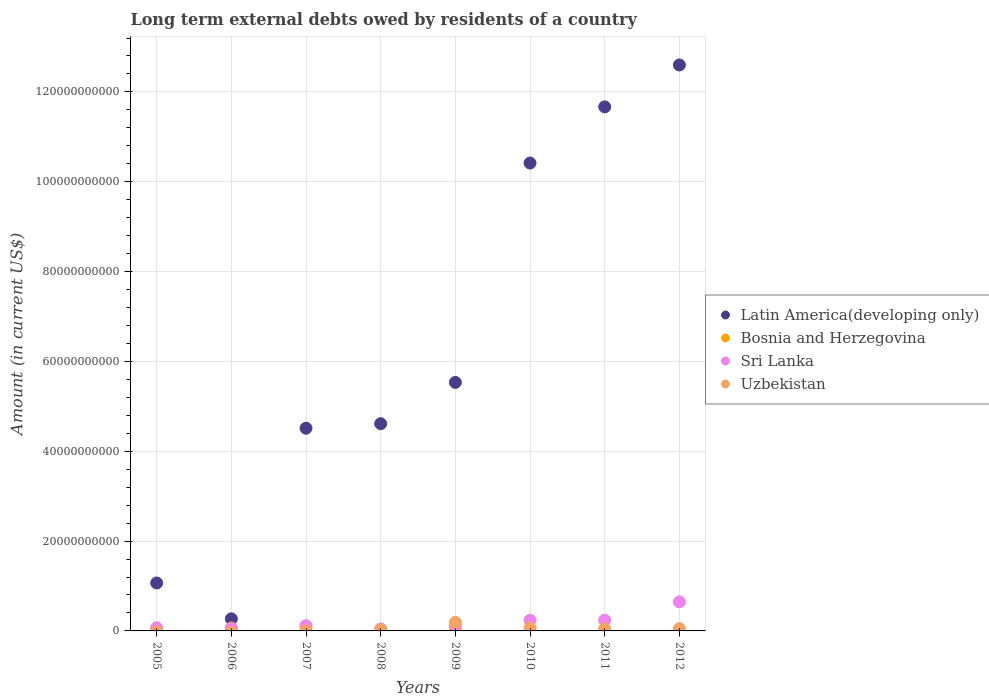Is the number of dotlines equal to the number of legend labels?
Offer a terse response. No. What is the amount of long-term external debts owed by residents in Sri Lanka in 2009?
Make the answer very short. 1.25e+09. Across all years, what is the maximum amount of long-term external debts owed by residents in Uzbekistan?
Offer a very short reply. 1.90e+09. Across all years, what is the minimum amount of long-term external debts owed by residents in Sri Lanka?
Offer a terse response. 4.30e+08. In which year was the amount of long-term external debts owed by residents in Sri Lanka maximum?
Provide a short and direct response. 2012. What is the total amount of long-term external debts owed by residents in Sri Lanka in the graph?
Offer a terse response. 1.53e+1. What is the difference between the amount of long-term external debts owed by residents in Sri Lanka in 2011 and that in 2012?
Ensure brevity in your answer.  -4.08e+09. What is the difference between the amount of long-term external debts owed by residents in Bosnia and Herzegovina in 2006 and the amount of long-term external debts owed by residents in Latin America(developing only) in 2007?
Your answer should be very brief. -4.45e+1. What is the average amount of long-term external debts owed by residents in Bosnia and Herzegovina per year?
Your response must be concise. 3.22e+08. In the year 2005, what is the difference between the amount of long-term external debts owed by residents in Bosnia and Herzegovina and amount of long-term external debts owed by residents in Latin America(developing only)?
Provide a succinct answer. -1.02e+1. What is the ratio of the amount of long-term external debts owed by residents in Uzbekistan in 2009 to that in 2012?
Provide a short and direct response. 3.71. What is the difference between the highest and the second highest amount of long-term external debts owed by residents in Uzbekistan?
Provide a succinct answer. 1.20e+09. What is the difference between the highest and the lowest amount of long-term external debts owed by residents in Bosnia and Herzegovina?
Offer a very short reply. 9.13e+08. Is it the case that in every year, the sum of the amount of long-term external debts owed by residents in Latin America(developing only) and amount of long-term external debts owed by residents in Bosnia and Herzegovina  is greater than the sum of amount of long-term external debts owed by residents in Uzbekistan and amount of long-term external debts owed by residents in Sri Lanka?
Keep it short and to the point. No. Is it the case that in every year, the sum of the amount of long-term external debts owed by residents in Latin America(developing only) and amount of long-term external debts owed by residents in Sri Lanka  is greater than the amount of long-term external debts owed by residents in Bosnia and Herzegovina?
Offer a very short reply. Yes. Does the amount of long-term external debts owed by residents in Bosnia and Herzegovina monotonically increase over the years?
Make the answer very short. No. What is the difference between two consecutive major ticks on the Y-axis?
Offer a very short reply. 2.00e+1. Are the values on the major ticks of Y-axis written in scientific E-notation?
Ensure brevity in your answer.  No. Does the graph contain any zero values?
Provide a succinct answer. Yes. Does the graph contain grids?
Keep it short and to the point. Yes. Where does the legend appear in the graph?
Offer a terse response. Center right. What is the title of the graph?
Offer a very short reply. Long term external debts owed by residents of a country. Does "Eritrea" appear as one of the legend labels in the graph?
Keep it short and to the point. No. What is the label or title of the Y-axis?
Provide a short and direct response. Amount (in current US$). What is the Amount (in current US$) in Latin America(developing only) in 2005?
Ensure brevity in your answer.  1.07e+1. What is the Amount (in current US$) in Bosnia and Herzegovina in 2005?
Offer a very short reply. 4.45e+08. What is the Amount (in current US$) in Sri Lanka in 2005?
Your answer should be compact. 6.84e+08. What is the Amount (in current US$) of Uzbekistan in 2005?
Provide a short and direct response. 0. What is the Amount (in current US$) of Latin America(developing only) in 2006?
Keep it short and to the point. 2.69e+09. What is the Amount (in current US$) of Bosnia and Herzegovina in 2006?
Give a very brief answer. 6.58e+08. What is the Amount (in current US$) in Sri Lanka in 2006?
Your answer should be compact. 5.33e+08. What is the Amount (in current US$) of Latin America(developing only) in 2007?
Offer a very short reply. 4.51e+1. What is the Amount (in current US$) in Bosnia and Herzegovina in 2007?
Make the answer very short. 9.13e+08. What is the Amount (in current US$) of Sri Lanka in 2007?
Your answer should be compact. 1.16e+09. What is the Amount (in current US$) of Uzbekistan in 2007?
Provide a short and direct response. 2.23e+07. What is the Amount (in current US$) of Latin America(developing only) in 2008?
Keep it short and to the point. 4.61e+1. What is the Amount (in current US$) in Bosnia and Herzegovina in 2008?
Ensure brevity in your answer.  3.35e+08. What is the Amount (in current US$) of Sri Lanka in 2008?
Offer a terse response. 4.30e+08. What is the Amount (in current US$) of Uzbekistan in 2008?
Your answer should be compact. 2.96e+08. What is the Amount (in current US$) of Latin America(developing only) in 2009?
Your answer should be very brief. 5.53e+1. What is the Amount (in current US$) in Bosnia and Herzegovina in 2009?
Offer a terse response. 2.23e+08. What is the Amount (in current US$) of Sri Lanka in 2009?
Provide a short and direct response. 1.25e+09. What is the Amount (in current US$) of Uzbekistan in 2009?
Your response must be concise. 1.90e+09. What is the Amount (in current US$) of Latin America(developing only) in 2010?
Ensure brevity in your answer.  1.04e+11. What is the Amount (in current US$) in Sri Lanka in 2010?
Give a very brief answer. 2.38e+09. What is the Amount (in current US$) in Uzbekistan in 2010?
Your response must be concise. 6.98e+08. What is the Amount (in current US$) in Latin America(developing only) in 2011?
Keep it short and to the point. 1.17e+11. What is the Amount (in current US$) in Sri Lanka in 2011?
Your answer should be compact. 2.39e+09. What is the Amount (in current US$) of Uzbekistan in 2011?
Provide a short and direct response. 4.87e+08. What is the Amount (in current US$) of Latin America(developing only) in 2012?
Provide a short and direct response. 1.26e+11. What is the Amount (in current US$) in Sri Lanka in 2012?
Provide a short and direct response. 6.47e+09. What is the Amount (in current US$) in Uzbekistan in 2012?
Keep it short and to the point. 5.12e+08. Across all years, what is the maximum Amount (in current US$) of Latin America(developing only)?
Make the answer very short. 1.26e+11. Across all years, what is the maximum Amount (in current US$) in Bosnia and Herzegovina?
Keep it short and to the point. 9.13e+08. Across all years, what is the maximum Amount (in current US$) in Sri Lanka?
Your response must be concise. 6.47e+09. Across all years, what is the maximum Amount (in current US$) in Uzbekistan?
Offer a very short reply. 1.90e+09. Across all years, what is the minimum Amount (in current US$) of Latin America(developing only)?
Make the answer very short. 2.69e+09. Across all years, what is the minimum Amount (in current US$) in Bosnia and Herzegovina?
Your response must be concise. 0. Across all years, what is the minimum Amount (in current US$) of Sri Lanka?
Your answer should be very brief. 4.30e+08. Across all years, what is the minimum Amount (in current US$) of Uzbekistan?
Your response must be concise. 0. What is the total Amount (in current US$) of Latin America(developing only) in the graph?
Offer a terse response. 5.07e+11. What is the total Amount (in current US$) of Bosnia and Herzegovina in the graph?
Offer a terse response. 2.57e+09. What is the total Amount (in current US$) in Sri Lanka in the graph?
Make the answer very short. 1.53e+1. What is the total Amount (in current US$) of Uzbekistan in the graph?
Provide a succinct answer. 3.91e+09. What is the difference between the Amount (in current US$) in Latin America(developing only) in 2005 and that in 2006?
Provide a short and direct response. 7.98e+09. What is the difference between the Amount (in current US$) in Bosnia and Herzegovina in 2005 and that in 2006?
Keep it short and to the point. -2.13e+08. What is the difference between the Amount (in current US$) in Sri Lanka in 2005 and that in 2006?
Offer a very short reply. 1.50e+08. What is the difference between the Amount (in current US$) of Latin America(developing only) in 2005 and that in 2007?
Make the answer very short. -3.45e+1. What is the difference between the Amount (in current US$) in Bosnia and Herzegovina in 2005 and that in 2007?
Provide a short and direct response. -4.69e+08. What is the difference between the Amount (in current US$) in Sri Lanka in 2005 and that in 2007?
Provide a succinct answer. -4.72e+08. What is the difference between the Amount (in current US$) of Latin America(developing only) in 2005 and that in 2008?
Give a very brief answer. -3.55e+1. What is the difference between the Amount (in current US$) of Bosnia and Herzegovina in 2005 and that in 2008?
Make the answer very short. 1.10e+08. What is the difference between the Amount (in current US$) of Sri Lanka in 2005 and that in 2008?
Your answer should be very brief. 2.54e+08. What is the difference between the Amount (in current US$) of Latin America(developing only) in 2005 and that in 2009?
Offer a very short reply. -4.46e+1. What is the difference between the Amount (in current US$) in Bosnia and Herzegovina in 2005 and that in 2009?
Your response must be concise. 2.21e+08. What is the difference between the Amount (in current US$) in Sri Lanka in 2005 and that in 2009?
Keep it short and to the point. -5.63e+08. What is the difference between the Amount (in current US$) in Latin America(developing only) in 2005 and that in 2010?
Ensure brevity in your answer.  -9.35e+1. What is the difference between the Amount (in current US$) of Sri Lanka in 2005 and that in 2010?
Give a very brief answer. -1.69e+09. What is the difference between the Amount (in current US$) of Latin America(developing only) in 2005 and that in 2011?
Offer a very short reply. -1.06e+11. What is the difference between the Amount (in current US$) of Sri Lanka in 2005 and that in 2011?
Provide a succinct answer. -1.71e+09. What is the difference between the Amount (in current US$) in Latin America(developing only) in 2005 and that in 2012?
Provide a short and direct response. -1.15e+11. What is the difference between the Amount (in current US$) of Sri Lanka in 2005 and that in 2012?
Ensure brevity in your answer.  -5.78e+09. What is the difference between the Amount (in current US$) of Latin America(developing only) in 2006 and that in 2007?
Your answer should be compact. -4.24e+1. What is the difference between the Amount (in current US$) in Bosnia and Herzegovina in 2006 and that in 2007?
Make the answer very short. -2.56e+08. What is the difference between the Amount (in current US$) of Sri Lanka in 2006 and that in 2007?
Keep it short and to the point. -6.22e+08. What is the difference between the Amount (in current US$) of Latin America(developing only) in 2006 and that in 2008?
Offer a terse response. -4.34e+1. What is the difference between the Amount (in current US$) of Bosnia and Herzegovina in 2006 and that in 2008?
Provide a short and direct response. 3.23e+08. What is the difference between the Amount (in current US$) of Sri Lanka in 2006 and that in 2008?
Your answer should be very brief. 1.04e+08. What is the difference between the Amount (in current US$) in Latin America(developing only) in 2006 and that in 2009?
Offer a very short reply. -5.26e+1. What is the difference between the Amount (in current US$) of Bosnia and Herzegovina in 2006 and that in 2009?
Make the answer very short. 4.34e+08. What is the difference between the Amount (in current US$) in Sri Lanka in 2006 and that in 2009?
Your answer should be compact. -7.14e+08. What is the difference between the Amount (in current US$) in Latin America(developing only) in 2006 and that in 2010?
Ensure brevity in your answer.  -1.01e+11. What is the difference between the Amount (in current US$) in Sri Lanka in 2006 and that in 2010?
Keep it short and to the point. -1.84e+09. What is the difference between the Amount (in current US$) in Latin America(developing only) in 2006 and that in 2011?
Offer a terse response. -1.14e+11. What is the difference between the Amount (in current US$) of Sri Lanka in 2006 and that in 2011?
Give a very brief answer. -1.86e+09. What is the difference between the Amount (in current US$) in Latin America(developing only) in 2006 and that in 2012?
Provide a short and direct response. -1.23e+11. What is the difference between the Amount (in current US$) in Sri Lanka in 2006 and that in 2012?
Ensure brevity in your answer.  -5.93e+09. What is the difference between the Amount (in current US$) of Latin America(developing only) in 2007 and that in 2008?
Your answer should be compact. -1.01e+09. What is the difference between the Amount (in current US$) in Bosnia and Herzegovina in 2007 and that in 2008?
Provide a short and direct response. 5.79e+08. What is the difference between the Amount (in current US$) of Sri Lanka in 2007 and that in 2008?
Ensure brevity in your answer.  7.26e+08. What is the difference between the Amount (in current US$) in Uzbekistan in 2007 and that in 2008?
Offer a very short reply. -2.74e+08. What is the difference between the Amount (in current US$) of Latin America(developing only) in 2007 and that in 2009?
Keep it short and to the point. -1.02e+1. What is the difference between the Amount (in current US$) in Bosnia and Herzegovina in 2007 and that in 2009?
Your answer should be very brief. 6.90e+08. What is the difference between the Amount (in current US$) in Sri Lanka in 2007 and that in 2009?
Give a very brief answer. -9.14e+07. What is the difference between the Amount (in current US$) in Uzbekistan in 2007 and that in 2009?
Provide a short and direct response. -1.88e+09. What is the difference between the Amount (in current US$) in Latin America(developing only) in 2007 and that in 2010?
Make the answer very short. -5.90e+1. What is the difference between the Amount (in current US$) of Sri Lanka in 2007 and that in 2010?
Your answer should be very brief. -1.22e+09. What is the difference between the Amount (in current US$) of Uzbekistan in 2007 and that in 2010?
Provide a short and direct response. -6.76e+08. What is the difference between the Amount (in current US$) of Latin America(developing only) in 2007 and that in 2011?
Your answer should be very brief. -7.15e+1. What is the difference between the Amount (in current US$) in Sri Lanka in 2007 and that in 2011?
Keep it short and to the point. -1.24e+09. What is the difference between the Amount (in current US$) of Uzbekistan in 2007 and that in 2011?
Give a very brief answer. -4.64e+08. What is the difference between the Amount (in current US$) in Latin America(developing only) in 2007 and that in 2012?
Keep it short and to the point. -8.09e+1. What is the difference between the Amount (in current US$) in Sri Lanka in 2007 and that in 2012?
Keep it short and to the point. -5.31e+09. What is the difference between the Amount (in current US$) in Uzbekistan in 2007 and that in 2012?
Make the answer very short. -4.90e+08. What is the difference between the Amount (in current US$) of Latin America(developing only) in 2008 and that in 2009?
Ensure brevity in your answer.  -9.19e+09. What is the difference between the Amount (in current US$) of Bosnia and Herzegovina in 2008 and that in 2009?
Provide a succinct answer. 1.11e+08. What is the difference between the Amount (in current US$) in Sri Lanka in 2008 and that in 2009?
Provide a short and direct response. -8.17e+08. What is the difference between the Amount (in current US$) in Uzbekistan in 2008 and that in 2009?
Keep it short and to the point. -1.60e+09. What is the difference between the Amount (in current US$) in Latin America(developing only) in 2008 and that in 2010?
Your response must be concise. -5.80e+1. What is the difference between the Amount (in current US$) in Sri Lanka in 2008 and that in 2010?
Keep it short and to the point. -1.95e+09. What is the difference between the Amount (in current US$) in Uzbekistan in 2008 and that in 2010?
Keep it short and to the point. -4.02e+08. What is the difference between the Amount (in current US$) of Latin America(developing only) in 2008 and that in 2011?
Give a very brief answer. -7.05e+1. What is the difference between the Amount (in current US$) in Sri Lanka in 2008 and that in 2011?
Provide a succinct answer. -1.96e+09. What is the difference between the Amount (in current US$) in Uzbekistan in 2008 and that in 2011?
Your response must be concise. -1.91e+08. What is the difference between the Amount (in current US$) of Latin America(developing only) in 2008 and that in 2012?
Offer a very short reply. -7.99e+1. What is the difference between the Amount (in current US$) in Sri Lanka in 2008 and that in 2012?
Ensure brevity in your answer.  -6.04e+09. What is the difference between the Amount (in current US$) in Uzbekistan in 2008 and that in 2012?
Provide a short and direct response. -2.16e+08. What is the difference between the Amount (in current US$) of Latin America(developing only) in 2009 and that in 2010?
Provide a succinct answer. -4.88e+1. What is the difference between the Amount (in current US$) in Sri Lanka in 2009 and that in 2010?
Make the answer very short. -1.13e+09. What is the difference between the Amount (in current US$) in Uzbekistan in 2009 and that in 2010?
Offer a very short reply. 1.20e+09. What is the difference between the Amount (in current US$) in Latin America(developing only) in 2009 and that in 2011?
Provide a succinct answer. -6.13e+1. What is the difference between the Amount (in current US$) in Sri Lanka in 2009 and that in 2011?
Your answer should be compact. -1.14e+09. What is the difference between the Amount (in current US$) in Uzbekistan in 2009 and that in 2011?
Your response must be concise. 1.41e+09. What is the difference between the Amount (in current US$) of Latin America(developing only) in 2009 and that in 2012?
Offer a terse response. -7.07e+1. What is the difference between the Amount (in current US$) of Sri Lanka in 2009 and that in 2012?
Your answer should be compact. -5.22e+09. What is the difference between the Amount (in current US$) in Uzbekistan in 2009 and that in 2012?
Provide a short and direct response. 1.39e+09. What is the difference between the Amount (in current US$) in Latin America(developing only) in 2010 and that in 2011?
Your answer should be very brief. -1.25e+1. What is the difference between the Amount (in current US$) in Sri Lanka in 2010 and that in 2011?
Give a very brief answer. -1.54e+07. What is the difference between the Amount (in current US$) in Uzbekistan in 2010 and that in 2011?
Provide a succinct answer. 2.11e+08. What is the difference between the Amount (in current US$) in Latin America(developing only) in 2010 and that in 2012?
Keep it short and to the point. -2.18e+1. What is the difference between the Amount (in current US$) in Sri Lanka in 2010 and that in 2012?
Ensure brevity in your answer.  -4.09e+09. What is the difference between the Amount (in current US$) in Uzbekistan in 2010 and that in 2012?
Your response must be concise. 1.86e+08. What is the difference between the Amount (in current US$) in Latin America(developing only) in 2011 and that in 2012?
Make the answer very short. -9.33e+09. What is the difference between the Amount (in current US$) of Sri Lanka in 2011 and that in 2012?
Offer a very short reply. -4.08e+09. What is the difference between the Amount (in current US$) of Uzbekistan in 2011 and that in 2012?
Provide a short and direct response. -2.52e+07. What is the difference between the Amount (in current US$) in Latin America(developing only) in 2005 and the Amount (in current US$) in Bosnia and Herzegovina in 2006?
Offer a very short reply. 1.00e+1. What is the difference between the Amount (in current US$) of Latin America(developing only) in 2005 and the Amount (in current US$) of Sri Lanka in 2006?
Offer a very short reply. 1.01e+1. What is the difference between the Amount (in current US$) of Bosnia and Herzegovina in 2005 and the Amount (in current US$) of Sri Lanka in 2006?
Provide a succinct answer. -8.87e+07. What is the difference between the Amount (in current US$) of Latin America(developing only) in 2005 and the Amount (in current US$) of Bosnia and Herzegovina in 2007?
Offer a very short reply. 9.76e+09. What is the difference between the Amount (in current US$) in Latin America(developing only) in 2005 and the Amount (in current US$) in Sri Lanka in 2007?
Ensure brevity in your answer.  9.52e+09. What is the difference between the Amount (in current US$) of Latin America(developing only) in 2005 and the Amount (in current US$) of Uzbekistan in 2007?
Provide a succinct answer. 1.07e+1. What is the difference between the Amount (in current US$) of Bosnia and Herzegovina in 2005 and the Amount (in current US$) of Sri Lanka in 2007?
Give a very brief answer. -7.11e+08. What is the difference between the Amount (in current US$) of Bosnia and Herzegovina in 2005 and the Amount (in current US$) of Uzbekistan in 2007?
Give a very brief answer. 4.22e+08. What is the difference between the Amount (in current US$) of Sri Lanka in 2005 and the Amount (in current US$) of Uzbekistan in 2007?
Keep it short and to the point. 6.62e+08. What is the difference between the Amount (in current US$) of Latin America(developing only) in 2005 and the Amount (in current US$) of Bosnia and Herzegovina in 2008?
Offer a terse response. 1.03e+1. What is the difference between the Amount (in current US$) of Latin America(developing only) in 2005 and the Amount (in current US$) of Sri Lanka in 2008?
Make the answer very short. 1.02e+1. What is the difference between the Amount (in current US$) in Latin America(developing only) in 2005 and the Amount (in current US$) in Uzbekistan in 2008?
Make the answer very short. 1.04e+1. What is the difference between the Amount (in current US$) of Bosnia and Herzegovina in 2005 and the Amount (in current US$) of Sri Lanka in 2008?
Make the answer very short. 1.50e+07. What is the difference between the Amount (in current US$) of Bosnia and Herzegovina in 2005 and the Amount (in current US$) of Uzbekistan in 2008?
Your answer should be compact. 1.48e+08. What is the difference between the Amount (in current US$) in Sri Lanka in 2005 and the Amount (in current US$) in Uzbekistan in 2008?
Keep it short and to the point. 3.88e+08. What is the difference between the Amount (in current US$) in Latin America(developing only) in 2005 and the Amount (in current US$) in Bosnia and Herzegovina in 2009?
Give a very brief answer. 1.05e+1. What is the difference between the Amount (in current US$) in Latin America(developing only) in 2005 and the Amount (in current US$) in Sri Lanka in 2009?
Ensure brevity in your answer.  9.43e+09. What is the difference between the Amount (in current US$) in Latin America(developing only) in 2005 and the Amount (in current US$) in Uzbekistan in 2009?
Give a very brief answer. 8.78e+09. What is the difference between the Amount (in current US$) in Bosnia and Herzegovina in 2005 and the Amount (in current US$) in Sri Lanka in 2009?
Keep it short and to the point. -8.02e+08. What is the difference between the Amount (in current US$) in Bosnia and Herzegovina in 2005 and the Amount (in current US$) in Uzbekistan in 2009?
Provide a short and direct response. -1.45e+09. What is the difference between the Amount (in current US$) of Sri Lanka in 2005 and the Amount (in current US$) of Uzbekistan in 2009?
Provide a short and direct response. -1.22e+09. What is the difference between the Amount (in current US$) in Latin America(developing only) in 2005 and the Amount (in current US$) in Sri Lanka in 2010?
Provide a short and direct response. 8.30e+09. What is the difference between the Amount (in current US$) in Latin America(developing only) in 2005 and the Amount (in current US$) in Uzbekistan in 2010?
Make the answer very short. 9.98e+09. What is the difference between the Amount (in current US$) in Bosnia and Herzegovina in 2005 and the Amount (in current US$) in Sri Lanka in 2010?
Your response must be concise. -1.93e+09. What is the difference between the Amount (in current US$) of Bosnia and Herzegovina in 2005 and the Amount (in current US$) of Uzbekistan in 2010?
Give a very brief answer. -2.53e+08. What is the difference between the Amount (in current US$) in Sri Lanka in 2005 and the Amount (in current US$) in Uzbekistan in 2010?
Offer a terse response. -1.40e+07. What is the difference between the Amount (in current US$) of Latin America(developing only) in 2005 and the Amount (in current US$) of Sri Lanka in 2011?
Ensure brevity in your answer.  8.28e+09. What is the difference between the Amount (in current US$) of Latin America(developing only) in 2005 and the Amount (in current US$) of Uzbekistan in 2011?
Your answer should be very brief. 1.02e+1. What is the difference between the Amount (in current US$) in Bosnia and Herzegovina in 2005 and the Amount (in current US$) in Sri Lanka in 2011?
Provide a succinct answer. -1.95e+09. What is the difference between the Amount (in current US$) in Bosnia and Herzegovina in 2005 and the Amount (in current US$) in Uzbekistan in 2011?
Your response must be concise. -4.22e+07. What is the difference between the Amount (in current US$) in Sri Lanka in 2005 and the Amount (in current US$) in Uzbekistan in 2011?
Keep it short and to the point. 1.97e+08. What is the difference between the Amount (in current US$) of Latin America(developing only) in 2005 and the Amount (in current US$) of Sri Lanka in 2012?
Provide a succinct answer. 4.21e+09. What is the difference between the Amount (in current US$) of Latin America(developing only) in 2005 and the Amount (in current US$) of Uzbekistan in 2012?
Offer a very short reply. 1.02e+1. What is the difference between the Amount (in current US$) of Bosnia and Herzegovina in 2005 and the Amount (in current US$) of Sri Lanka in 2012?
Provide a succinct answer. -6.02e+09. What is the difference between the Amount (in current US$) of Bosnia and Herzegovina in 2005 and the Amount (in current US$) of Uzbekistan in 2012?
Provide a short and direct response. -6.74e+07. What is the difference between the Amount (in current US$) of Sri Lanka in 2005 and the Amount (in current US$) of Uzbekistan in 2012?
Your response must be concise. 1.72e+08. What is the difference between the Amount (in current US$) in Latin America(developing only) in 2006 and the Amount (in current US$) in Bosnia and Herzegovina in 2007?
Provide a succinct answer. 1.78e+09. What is the difference between the Amount (in current US$) of Latin America(developing only) in 2006 and the Amount (in current US$) of Sri Lanka in 2007?
Keep it short and to the point. 1.54e+09. What is the difference between the Amount (in current US$) of Latin America(developing only) in 2006 and the Amount (in current US$) of Uzbekistan in 2007?
Keep it short and to the point. 2.67e+09. What is the difference between the Amount (in current US$) of Bosnia and Herzegovina in 2006 and the Amount (in current US$) of Sri Lanka in 2007?
Provide a succinct answer. -4.98e+08. What is the difference between the Amount (in current US$) of Bosnia and Herzegovina in 2006 and the Amount (in current US$) of Uzbekistan in 2007?
Give a very brief answer. 6.35e+08. What is the difference between the Amount (in current US$) in Sri Lanka in 2006 and the Amount (in current US$) in Uzbekistan in 2007?
Provide a short and direct response. 5.11e+08. What is the difference between the Amount (in current US$) in Latin America(developing only) in 2006 and the Amount (in current US$) in Bosnia and Herzegovina in 2008?
Give a very brief answer. 2.36e+09. What is the difference between the Amount (in current US$) of Latin America(developing only) in 2006 and the Amount (in current US$) of Sri Lanka in 2008?
Your response must be concise. 2.26e+09. What is the difference between the Amount (in current US$) of Latin America(developing only) in 2006 and the Amount (in current US$) of Uzbekistan in 2008?
Provide a succinct answer. 2.40e+09. What is the difference between the Amount (in current US$) of Bosnia and Herzegovina in 2006 and the Amount (in current US$) of Sri Lanka in 2008?
Offer a very short reply. 2.28e+08. What is the difference between the Amount (in current US$) in Bosnia and Herzegovina in 2006 and the Amount (in current US$) in Uzbekistan in 2008?
Provide a succinct answer. 3.62e+08. What is the difference between the Amount (in current US$) in Sri Lanka in 2006 and the Amount (in current US$) in Uzbekistan in 2008?
Your answer should be very brief. 2.37e+08. What is the difference between the Amount (in current US$) in Latin America(developing only) in 2006 and the Amount (in current US$) in Bosnia and Herzegovina in 2009?
Your answer should be very brief. 2.47e+09. What is the difference between the Amount (in current US$) of Latin America(developing only) in 2006 and the Amount (in current US$) of Sri Lanka in 2009?
Keep it short and to the point. 1.45e+09. What is the difference between the Amount (in current US$) in Latin America(developing only) in 2006 and the Amount (in current US$) in Uzbekistan in 2009?
Your answer should be compact. 7.94e+08. What is the difference between the Amount (in current US$) in Bosnia and Herzegovina in 2006 and the Amount (in current US$) in Sri Lanka in 2009?
Your answer should be compact. -5.89e+08. What is the difference between the Amount (in current US$) in Bosnia and Herzegovina in 2006 and the Amount (in current US$) in Uzbekistan in 2009?
Keep it short and to the point. -1.24e+09. What is the difference between the Amount (in current US$) in Sri Lanka in 2006 and the Amount (in current US$) in Uzbekistan in 2009?
Your answer should be very brief. -1.37e+09. What is the difference between the Amount (in current US$) of Latin America(developing only) in 2006 and the Amount (in current US$) of Sri Lanka in 2010?
Keep it short and to the point. 3.18e+08. What is the difference between the Amount (in current US$) of Latin America(developing only) in 2006 and the Amount (in current US$) of Uzbekistan in 2010?
Make the answer very short. 2.00e+09. What is the difference between the Amount (in current US$) in Bosnia and Herzegovina in 2006 and the Amount (in current US$) in Sri Lanka in 2010?
Provide a succinct answer. -1.72e+09. What is the difference between the Amount (in current US$) in Bosnia and Herzegovina in 2006 and the Amount (in current US$) in Uzbekistan in 2010?
Your answer should be very brief. -4.01e+07. What is the difference between the Amount (in current US$) in Sri Lanka in 2006 and the Amount (in current US$) in Uzbekistan in 2010?
Keep it short and to the point. -1.64e+08. What is the difference between the Amount (in current US$) in Latin America(developing only) in 2006 and the Amount (in current US$) in Sri Lanka in 2011?
Your response must be concise. 3.03e+08. What is the difference between the Amount (in current US$) of Latin America(developing only) in 2006 and the Amount (in current US$) of Uzbekistan in 2011?
Provide a succinct answer. 2.21e+09. What is the difference between the Amount (in current US$) in Bosnia and Herzegovina in 2006 and the Amount (in current US$) in Sri Lanka in 2011?
Ensure brevity in your answer.  -1.73e+09. What is the difference between the Amount (in current US$) in Bosnia and Herzegovina in 2006 and the Amount (in current US$) in Uzbekistan in 2011?
Offer a very short reply. 1.71e+08. What is the difference between the Amount (in current US$) of Sri Lanka in 2006 and the Amount (in current US$) of Uzbekistan in 2011?
Make the answer very short. 4.66e+07. What is the difference between the Amount (in current US$) in Latin America(developing only) in 2006 and the Amount (in current US$) in Sri Lanka in 2012?
Provide a succinct answer. -3.77e+09. What is the difference between the Amount (in current US$) in Latin America(developing only) in 2006 and the Amount (in current US$) in Uzbekistan in 2012?
Make the answer very short. 2.18e+09. What is the difference between the Amount (in current US$) of Bosnia and Herzegovina in 2006 and the Amount (in current US$) of Sri Lanka in 2012?
Provide a succinct answer. -5.81e+09. What is the difference between the Amount (in current US$) of Bosnia and Herzegovina in 2006 and the Amount (in current US$) of Uzbekistan in 2012?
Ensure brevity in your answer.  1.46e+08. What is the difference between the Amount (in current US$) in Sri Lanka in 2006 and the Amount (in current US$) in Uzbekistan in 2012?
Ensure brevity in your answer.  2.13e+07. What is the difference between the Amount (in current US$) in Latin America(developing only) in 2007 and the Amount (in current US$) in Bosnia and Herzegovina in 2008?
Your answer should be very brief. 4.48e+1. What is the difference between the Amount (in current US$) of Latin America(developing only) in 2007 and the Amount (in current US$) of Sri Lanka in 2008?
Make the answer very short. 4.47e+1. What is the difference between the Amount (in current US$) in Latin America(developing only) in 2007 and the Amount (in current US$) in Uzbekistan in 2008?
Offer a terse response. 4.48e+1. What is the difference between the Amount (in current US$) in Bosnia and Herzegovina in 2007 and the Amount (in current US$) in Sri Lanka in 2008?
Provide a short and direct response. 4.84e+08. What is the difference between the Amount (in current US$) of Bosnia and Herzegovina in 2007 and the Amount (in current US$) of Uzbekistan in 2008?
Keep it short and to the point. 6.17e+08. What is the difference between the Amount (in current US$) of Sri Lanka in 2007 and the Amount (in current US$) of Uzbekistan in 2008?
Offer a very short reply. 8.59e+08. What is the difference between the Amount (in current US$) of Latin America(developing only) in 2007 and the Amount (in current US$) of Bosnia and Herzegovina in 2009?
Ensure brevity in your answer.  4.49e+1. What is the difference between the Amount (in current US$) of Latin America(developing only) in 2007 and the Amount (in current US$) of Sri Lanka in 2009?
Your answer should be compact. 4.39e+1. What is the difference between the Amount (in current US$) of Latin America(developing only) in 2007 and the Amount (in current US$) of Uzbekistan in 2009?
Keep it short and to the point. 4.32e+1. What is the difference between the Amount (in current US$) of Bosnia and Herzegovina in 2007 and the Amount (in current US$) of Sri Lanka in 2009?
Your answer should be very brief. -3.34e+08. What is the difference between the Amount (in current US$) of Bosnia and Herzegovina in 2007 and the Amount (in current US$) of Uzbekistan in 2009?
Offer a terse response. -9.86e+08. What is the difference between the Amount (in current US$) of Sri Lanka in 2007 and the Amount (in current US$) of Uzbekistan in 2009?
Offer a terse response. -7.44e+08. What is the difference between the Amount (in current US$) of Latin America(developing only) in 2007 and the Amount (in current US$) of Sri Lanka in 2010?
Your response must be concise. 4.28e+1. What is the difference between the Amount (in current US$) of Latin America(developing only) in 2007 and the Amount (in current US$) of Uzbekistan in 2010?
Your answer should be very brief. 4.44e+1. What is the difference between the Amount (in current US$) of Bosnia and Herzegovina in 2007 and the Amount (in current US$) of Sri Lanka in 2010?
Give a very brief answer. -1.46e+09. What is the difference between the Amount (in current US$) in Bosnia and Herzegovina in 2007 and the Amount (in current US$) in Uzbekistan in 2010?
Keep it short and to the point. 2.16e+08. What is the difference between the Amount (in current US$) in Sri Lanka in 2007 and the Amount (in current US$) in Uzbekistan in 2010?
Provide a short and direct response. 4.58e+08. What is the difference between the Amount (in current US$) in Latin America(developing only) in 2007 and the Amount (in current US$) in Sri Lanka in 2011?
Give a very brief answer. 4.27e+1. What is the difference between the Amount (in current US$) of Latin America(developing only) in 2007 and the Amount (in current US$) of Uzbekistan in 2011?
Give a very brief answer. 4.46e+1. What is the difference between the Amount (in current US$) in Bosnia and Herzegovina in 2007 and the Amount (in current US$) in Sri Lanka in 2011?
Make the answer very short. -1.48e+09. What is the difference between the Amount (in current US$) in Bosnia and Herzegovina in 2007 and the Amount (in current US$) in Uzbekistan in 2011?
Provide a succinct answer. 4.27e+08. What is the difference between the Amount (in current US$) of Sri Lanka in 2007 and the Amount (in current US$) of Uzbekistan in 2011?
Provide a succinct answer. 6.69e+08. What is the difference between the Amount (in current US$) in Latin America(developing only) in 2007 and the Amount (in current US$) in Sri Lanka in 2012?
Ensure brevity in your answer.  3.87e+1. What is the difference between the Amount (in current US$) of Latin America(developing only) in 2007 and the Amount (in current US$) of Uzbekistan in 2012?
Keep it short and to the point. 4.46e+1. What is the difference between the Amount (in current US$) of Bosnia and Herzegovina in 2007 and the Amount (in current US$) of Sri Lanka in 2012?
Offer a very short reply. -5.55e+09. What is the difference between the Amount (in current US$) of Bosnia and Herzegovina in 2007 and the Amount (in current US$) of Uzbekistan in 2012?
Give a very brief answer. 4.01e+08. What is the difference between the Amount (in current US$) of Sri Lanka in 2007 and the Amount (in current US$) of Uzbekistan in 2012?
Give a very brief answer. 6.44e+08. What is the difference between the Amount (in current US$) in Latin America(developing only) in 2008 and the Amount (in current US$) in Bosnia and Herzegovina in 2009?
Provide a short and direct response. 4.59e+1. What is the difference between the Amount (in current US$) in Latin America(developing only) in 2008 and the Amount (in current US$) in Sri Lanka in 2009?
Offer a very short reply. 4.49e+1. What is the difference between the Amount (in current US$) of Latin America(developing only) in 2008 and the Amount (in current US$) of Uzbekistan in 2009?
Offer a very short reply. 4.42e+1. What is the difference between the Amount (in current US$) in Bosnia and Herzegovina in 2008 and the Amount (in current US$) in Sri Lanka in 2009?
Your answer should be compact. -9.12e+08. What is the difference between the Amount (in current US$) of Bosnia and Herzegovina in 2008 and the Amount (in current US$) of Uzbekistan in 2009?
Make the answer very short. -1.56e+09. What is the difference between the Amount (in current US$) in Sri Lanka in 2008 and the Amount (in current US$) in Uzbekistan in 2009?
Your response must be concise. -1.47e+09. What is the difference between the Amount (in current US$) of Latin America(developing only) in 2008 and the Amount (in current US$) of Sri Lanka in 2010?
Provide a short and direct response. 4.38e+1. What is the difference between the Amount (in current US$) in Latin America(developing only) in 2008 and the Amount (in current US$) in Uzbekistan in 2010?
Provide a succinct answer. 4.54e+1. What is the difference between the Amount (in current US$) in Bosnia and Herzegovina in 2008 and the Amount (in current US$) in Sri Lanka in 2010?
Provide a short and direct response. -2.04e+09. What is the difference between the Amount (in current US$) of Bosnia and Herzegovina in 2008 and the Amount (in current US$) of Uzbekistan in 2010?
Provide a short and direct response. -3.63e+08. What is the difference between the Amount (in current US$) in Sri Lanka in 2008 and the Amount (in current US$) in Uzbekistan in 2010?
Give a very brief answer. -2.68e+08. What is the difference between the Amount (in current US$) in Latin America(developing only) in 2008 and the Amount (in current US$) in Sri Lanka in 2011?
Provide a short and direct response. 4.37e+1. What is the difference between the Amount (in current US$) of Latin America(developing only) in 2008 and the Amount (in current US$) of Uzbekistan in 2011?
Provide a succinct answer. 4.56e+1. What is the difference between the Amount (in current US$) in Bosnia and Herzegovina in 2008 and the Amount (in current US$) in Sri Lanka in 2011?
Make the answer very short. -2.06e+09. What is the difference between the Amount (in current US$) of Bosnia and Herzegovina in 2008 and the Amount (in current US$) of Uzbekistan in 2011?
Offer a very short reply. -1.52e+08. What is the difference between the Amount (in current US$) of Sri Lanka in 2008 and the Amount (in current US$) of Uzbekistan in 2011?
Offer a terse response. -5.72e+07. What is the difference between the Amount (in current US$) of Latin America(developing only) in 2008 and the Amount (in current US$) of Sri Lanka in 2012?
Give a very brief answer. 3.97e+1. What is the difference between the Amount (in current US$) of Latin America(developing only) in 2008 and the Amount (in current US$) of Uzbekistan in 2012?
Provide a succinct answer. 4.56e+1. What is the difference between the Amount (in current US$) in Bosnia and Herzegovina in 2008 and the Amount (in current US$) in Sri Lanka in 2012?
Your answer should be compact. -6.13e+09. What is the difference between the Amount (in current US$) of Bosnia and Herzegovina in 2008 and the Amount (in current US$) of Uzbekistan in 2012?
Make the answer very short. -1.77e+08. What is the difference between the Amount (in current US$) in Sri Lanka in 2008 and the Amount (in current US$) in Uzbekistan in 2012?
Your answer should be very brief. -8.24e+07. What is the difference between the Amount (in current US$) of Latin America(developing only) in 2009 and the Amount (in current US$) of Sri Lanka in 2010?
Keep it short and to the point. 5.29e+1. What is the difference between the Amount (in current US$) of Latin America(developing only) in 2009 and the Amount (in current US$) of Uzbekistan in 2010?
Keep it short and to the point. 5.46e+1. What is the difference between the Amount (in current US$) in Bosnia and Herzegovina in 2009 and the Amount (in current US$) in Sri Lanka in 2010?
Your answer should be compact. -2.15e+09. What is the difference between the Amount (in current US$) in Bosnia and Herzegovina in 2009 and the Amount (in current US$) in Uzbekistan in 2010?
Provide a succinct answer. -4.74e+08. What is the difference between the Amount (in current US$) of Sri Lanka in 2009 and the Amount (in current US$) of Uzbekistan in 2010?
Offer a very short reply. 5.49e+08. What is the difference between the Amount (in current US$) of Latin America(developing only) in 2009 and the Amount (in current US$) of Sri Lanka in 2011?
Keep it short and to the point. 5.29e+1. What is the difference between the Amount (in current US$) in Latin America(developing only) in 2009 and the Amount (in current US$) in Uzbekistan in 2011?
Provide a short and direct response. 5.48e+1. What is the difference between the Amount (in current US$) of Bosnia and Herzegovina in 2009 and the Amount (in current US$) of Sri Lanka in 2011?
Your response must be concise. -2.17e+09. What is the difference between the Amount (in current US$) in Bosnia and Herzegovina in 2009 and the Amount (in current US$) in Uzbekistan in 2011?
Offer a terse response. -2.63e+08. What is the difference between the Amount (in current US$) in Sri Lanka in 2009 and the Amount (in current US$) in Uzbekistan in 2011?
Give a very brief answer. 7.60e+08. What is the difference between the Amount (in current US$) of Latin America(developing only) in 2009 and the Amount (in current US$) of Sri Lanka in 2012?
Your response must be concise. 4.89e+1. What is the difference between the Amount (in current US$) in Latin America(developing only) in 2009 and the Amount (in current US$) in Uzbekistan in 2012?
Ensure brevity in your answer.  5.48e+1. What is the difference between the Amount (in current US$) of Bosnia and Herzegovina in 2009 and the Amount (in current US$) of Sri Lanka in 2012?
Make the answer very short. -6.24e+09. What is the difference between the Amount (in current US$) in Bosnia and Herzegovina in 2009 and the Amount (in current US$) in Uzbekistan in 2012?
Provide a short and direct response. -2.89e+08. What is the difference between the Amount (in current US$) in Sri Lanka in 2009 and the Amount (in current US$) in Uzbekistan in 2012?
Give a very brief answer. 7.35e+08. What is the difference between the Amount (in current US$) in Latin America(developing only) in 2010 and the Amount (in current US$) in Sri Lanka in 2011?
Provide a succinct answer. 1.02e+11. What is the difference between the Amount (in current US$) of Latin America(developing only) in 2010 and the Amount (in current US$) of Uzbekistan in 2011?
Offer a terse response. 1.04e+11. What is the difference between the Amount (in current US$) in Sri Lanka in 2010 and the Amount (in current US$) in Uzbekistan in 2011?
Ensure brevity in your answer.  1.89e+09. What is the difference between the Amount (in current US$) of Latin America(developing only) in 2010 and the Amount (in current US$) of Sri Lanka in 2012?
Your response must be concise. 9.77e+1. What is the difference between the Amount (in current US$) of Latin America(developing only) in 2010 and the Amount (in current US$) of Uzbekistan in 2012?
Your answer should be compact. 1.04e+11. What is the difference between the Amount (in current US$) of Sri Lanka in 2010 and the Amount (in current US$) of Uzbekistan in 2012?
Your answer should be very brief. 1.86e+09. What is the difference between the Amount (in current US$) of Latin America(developing only) in 2011 and the Amount (in current US$) of Sri Lanka in 2012?
Your response must be concise. 1.10e+11. What is the difference between the Amount (in current US$) in Latin America(developing only) in 2011 and the Amount (in current US$) in Uzbekistan in 2012?
Offer a terse response. 1.16e+11. What is the difference between the Amount (in current US$) in Sri Lanka in 2011 and the Amount (in current US$) in Uzbekistan in 2012?
Make the answer very short. 1.88e+09. What is the average Amount (in current US$) of Latin America(developing only) per year?
Provide a succinct answer. 6.33e+1. What is the average Amount (in current US$) of Bosnia and Herzegovina per year?
Ensure brevity in your answer.  3.22e+08. What is the average Amount (in current US$) in Sri Lanka per year?
Give a very brief answer. 1.91e+09. What is the average Amount (in current US$) of Uzbekistan per year?
Keep it short and to the point. 4.89e+08. In the year 2005, what is the difference between the Amount (in current US$) of Latin America(developing only) and Amount (in current US$) of Bosnia and Herzegovina?
Your answer should be very brief. 1.02e+1. In the year 2005, what is the difference between the Amount (in current US$) in Latin America(developing only) and Amount (in current US$) in Sri Lanka?
Your response must be concise. 9.99e+09. In the year 2005, what is the difference between the Amount (in current US$) of Bosnia and Herzegovina and Amount (in current US$) of Sri Lanka?
Provide a succinct answer. -2.39e+08. In the year 2006, what is the difference between the Amount (in current US$) in Latin America(developing only) and Amount (in current US$) in Bosnia and Herzegovina?
Provide a short and direct response. 2.04e+09. In the year 2006, what is the difference between the Amount (in current US$) in Latin America(developing only) and Amount (in current US$) in Sri Lanka?
Your response must be concise. 2.16e+09. In the year 2006, what is the difference between the Amount (in current US$) of Bosnia and Herzegovina and Amount (in current US$) of Sri Lanka?
Provide a succinct answer. 1.24e+08. In the year 2007, what is the difference between the Amount (in current US$) of Latin America(developing only) and Amount (in current US$) of Bosnia and Herzegovina?
Give a very brief answer. 4.42e+1. In the year 2007, what is the difference between the Amount (in current US$) in Latin America(developing only) and Amount (in current US$) in Sri Lanka?
Offer a terse response. 4.40e+1. In the year 2007, what is the difference between the Amount (in current US$) of Latin America(developing only) and Amount (in current US$) of Uzbekistan?
Give a very brief answer. 4.51e+1. In the year 2007, what is the difference between the Amount (in current US$) in Bosnia and Herzegovina and Amount (in current US$) in Sri Lanka?
Provide a short and direct response. -2.42e+08. In the year 2007, what is the difference between the Amount (in current US$) in Bosnia and Herzegovina and Amount (in current US$) in Uzbekistan?
Offer a terse response. 8.91e+08. In the year 2007, what is the difference between the Amount (in current US$) of Sri Lanka and Amount (in current US$) of Uzbekistan?
Offer a very short reply. 1.13e+09. In the year 2008, what is the difference between the Amount (in current US$) in Latin America(developing only) and Amount (in current US$) in Bosnia and Herzegovina?
Provide a short and direct response. 4.58e+1. In the year 2008, what is the difference between the Amount (in current US$) in Latin America(developing only) and Amount (in current US$) in Sri Lanka?
Ensure brevity in your answer.  4.57e+1. In the year 2008, what is the difference between the Amount (in current US$) in Latin America(developing only) and Amount (in current US$) in Uzbekistan?
Your answer should be compact. 4.58e+1. In the year 2008, what is the difference between the Amount (in current US$) in Bosnia and Herzegovina and Amount (in current US$) in Sri Lanka?
Ensure brevity in your answer.  -9.49e+07. In the year 2008, what is the difference between the Amount (in current US$) in Bosnia and Herzegovina and Amount (in current US$) in Uzbekistan?
Provide a short and direct response. 3.86e+07. In the year 2008, what is the difference between the Amount (in current US$) in Sri Lanka and Amount (in current US$) in Uzbekistan?
Offer a terse response. 1.33e+08. In the year 2009, what is the difference between the Amount (in current US$) of Latin America(developing only) and Amount (in current US$) of Bosnia and Herzegovina?
Make the answer very short. 5.51e+1. In the year 2009, what is the difference between the Amount (in current US$) of Latin America(developing only) and Amount (in current US$) of Sri Lanka?
Provide a succinct answer. 5.41e+1. In the year 2009, what is the difference between the Amount (in current US$) in Latin America(developing only) and Amount (in current US$) in Uzbekistan?
Make the answer very short. 5.34e+1. In the year 2009, what is the difference between the Amount (in current US$) in Bosnia and Herzegovina and Amount (in current US$) in Sri Lanka?
Make the answer very short. -1.02e+09. In the year 2009, what is the difference between the Amount (in current US$) of Bosnia and Herzegovina and Amount (in current US$) of Uzbekistan?
Give a very brief answer. -1.68e+09. In the year 2009, what is the difference between the Amount (in current US$) in Sri Lanka and Amount (in current US$) in Uzbekistan?
Make the answer very short. -6.52e+08. In the year 2010, what is the difference between the Amount (in current US$) of Latin America(developing only) and Amount (in current US$) of Sri Lanka?
Your answer should be compact. 1.02e+11. In the year 2010, what is the difference between the Amount (in current US$) in Latin America(developing only) and Amount (in current US$) in Uzbekistan?
Ensure brevity in your answer.  1.03e+11. In the year 2010, what is the difference between the Amount (in current US$) of Sri Lanka and Amount (in current US$) of Uzbekistan?
Your answer should be compact. 1.68e+09. In the year 2011, what is the difference between the Amount (in current US$) of Latin America(developing only) and Amount (in current US$) of Sri Lanka?
Your response must be concise. 1.14e+11. In the year 2011, what is the difference between the Amount (in current US$) of Latin America(developing only) and Amount (in current US$) of Uzbekistan?
Keep it short and to the point. 1.16e+11. In the year 2011, what is the difference between the Amount (in current US$) of Sri Lanka and Amount (in current US$) of Uzbekistan?
Make the answer very short. 1.90e+09. In the year 2012, what is the difference between the Amount (in current US$) of Latin America(developing only) and Amount (in current US$) of Sri Lanka?
Offer a very short reply. 1.20e+11. In the year 2012, what is the difference between the Amount (in current US$) of Latin America(developing only) and Amount (in current US$) of Uzbekistan?
Your answer should be compact. 1.25e+11. In the year 2012, what is the difference between the Amount (in current US$) in Sri Lanka and Amount (in current US$) in Uzbekistan?
Give a very brief answer. 5.96e+09. What is the ratio of the Amount (in current US$) of Latin America(developing only) in 2005 to that in 2006?
Ensure brevity in your answer.  3.96. What is the ratio of the Amount (in current US$) in Bosnia and Herzegovina in 2005 to that in 2006?
Provide a short and direct response. 0.68. What is the ratio of the Amount (in current US$) in Sri Lanka in 2005 to that in 2006?
Provide a succinct answer. 1.28. What is the ratio of the Amount (in current US$) in Latin America(developing only) in 2005 to that in 2007?
Offer a very short reply. 0.24. What is the ratio of the Amount (in current US$) in Bosnia and Herzegovina in 2005 to that in 2007?
Your answer should be very brief. 0.49. What is the ratio of the Amount (in current US$) in Sri Lanka in 2005 to that in 2007?
Offer a terse response. 0.59. What is the ratio of the Amount (in current US$) in Latin America(developing only) in 2005 to that in 2008?
Your answer should be very brief. 0.23. What is the ratio of the Amount (in current US$) in Bosnia and Herzegovina in 2005 to that in 2008?
Provide a short and direct response. 1.33. What is the ratio of the Amount (in current US$) of Sri Lanka in 2005 to that in 2008?
Provide a succinct answer. 1.59. What is the ratio of the Amount (in current US$) of Latin America(developing only) in 2005 to that in 2009?
Provide a succinct answer. 0.19. What is the ratio of the Amount (in current US$) of Bosnia and Herzegovina in 2005 to that in 2009?
Offer a terse response. 1.99. What is the ratio of the Amount (in current US$) in Sri Lanka in 2005 to that in 2009?
Keep it short and to the point. 0.55. What is the ratio of the Amount (in current US$) of Latin America(developing only) in 2005 to that in 2010?
Keep it short and to the point. 0.1. What is the ratio of the Amount (in current US$) of Sri Lanka in 2005 to that in 2010?
Provide a short and direct response. 0.29. What is the ratio of the Amount (in current US$) in Latin America(developing only) in 2005 to that in 2011?
Offer a terse response. 0.09. What is the ratio of the Amount (in current US$) of Sri Lanka in 2005 to that in 2011?
Give a very brief answer. 0.29. What is the ratio of the Amount (in current US$) of Latin America(developing only) in 2005 to that in 2012?
Offer a very short reply. 0.08. What is the ratio of the Amount (in current US$) in Sri Lanka in 2005 to that in 2012?
Your response must be concise. 0.11. What is the ratio of the Amount (in current US$) of Latin America(developing only) in 2006 to that in 2007?
Keep it short and to the point. 0.06. What is the ratio of the Amount (in current US$) in Bosnia and Herzegovina in 2006 to that in 2007?
Your answer should be compact. 0.72. What is the ratio of the Amount (in current US$) in Sri Lanka in 2006 to that in 2007?
Make the answer very short. 0.46. What is the ratio of the Amount (in current US$) of Latin America(developing only) in 2006 to that in 2008?
Keep it short and to the point. 0.06. What is the ratio of the Amount (in current US$) of Bosnia and Herzegovina in 2006 to that in 2008?
Your response must be concise. 1.96. What is the ratio of the Amount (in current US$) of Sri Lanka in 2006 to that in 2008?
Keep it short and to the point. 1.24. What is the ratio of the Amount (in current US$) in Latin America(developing only) in 2006 to that in 2009?
Offer a very short reply. 0.05. What is the ratio of the Amount (in current US$) in Bosnia and Herzegovina in 2006 to that in 2009?
Your response must be concise. 2.94. What is the ratio of the Amount (in current US$) in Sri Lanka in 2006 to that in 2009?
Provide a succinct answer. 0.43. What is the ratio of the Amount (in current US$) in Latin America(developing only) in 2006 to that in 2010?
Your answer should be very brief. 0.03. What is the ratio of the Amount (in current US$) of Sri Lanka in 2006 to that in 2010?
Your response must be concise. 0.22. What is the ratio of the Amount (in current US$) in Latin America(developing only) in 2006 to that in 2011?
Make the answer very short. 0.02. What is the ratio of the Amount (in current US$) of Sri Lanka in 2006 to that in 2011?
Give a very brief answer. 0.22. What is the ratio of the Amount (in current US$) of Latin America(developing only) in 2006 to that in 2012?
Provide a succinct answer. 0.02. What is the ratio of the Amount (in current US$) in Sri Lanka in 2006 to that in 2012?
Offer a very short reply. 0.08. What is the ratio of the Amount (in current US$) of Latin America(developing only) in 2007 to that in 2008?
Provide a succinct answer. 0.98. What is the ratio of the Amount (in current US$) of Bosnia and Herzegovina in 2007 to that in 2008?
Give a very brief answer. 2.73. What is the ratio of the Amount (in current US$) in Sri Lanka in 2007 to that in 2008?
Ensure brevity in your answer.  2.69. What is the ratio of the Amount (in current US$) of Uzbekistan in 2007 to that in 2008?
Provide a succinct answer. 0.08. What is the ratio of the Amount (in current US$) of Latin America(developing only) in 2007 to that in 2009?
Give a very brief answer. 0.82. What is the ratio of the Amount (in current US$) in Bosnia and Herzegovina in 2007 to that in 2009?
Keep it short and to the point. 4.09. What is the ratio of the Amount (in current US$) in Sri Lanka in 2007 to that in 2009?
Keep it short and to the point. 0.93. What is the ratio of the Amount (in current US$) of Uzbekistan in 2007 to that in 2009?
Keep it short and to the point. 0.01. What is the ratio of the Amount (in current US$) in Latin America(developing only) in 2007 to that in 2010?
Give a very brief answer. 0.43. What is the ratio of the Amount (in current US$) of Sri Lanka in 2007 to that in 2010?
Provide a succinct answer. 0.49. What is the ratio of the Amount (in current US$) in Uzbekistan in 2007 to that in 2010?
Offer a terse response. 0.03. What is the ratio of the Amount (in current US$) in Latin America(developing only) in 2007 to that in 2011?
Offer a terse response. 0.39. What is the ratio of the Amount (in current US$) of Sri Lanka in 2007 to that in 2011?
Offer a very short reply. 0.48. What is the ratio of the Amount (in current US$) of Uzbekistan in 2007 to that in 2011?
Give a very brief answer. 0.05. What is the ratio of the Amount (in current US$) of Latin America(developing only) in 2007 to that in 2012?
Offer a very short reply. 0.36. What is the ratio of the Amount (in current US$) in Sri Lanka in 2007 to that in 2012?
Give a very brief answer. 0.18. What is the ratio of the Amount (in current US$) in Uzbekistan in 2007 to that in 2012?
Provide a short and direct response. 0.04. What is the ratio of the Amount (in current US$) in Latin America(developing only) in 2008 to that in 2009?
Provide a succinct answer. 0.83. What is the ratio of the Amount (in current US$) in Bosnia and Herzegovina in 2008 to that in 2009?
Provide a short and direct response. 1.5. What is the ratio of the Amount (in current US$) of Sri Lanka in 2008 to that in 2009?
Provide a short and direct response. 0.34. What is the ratio of the Amount (in current US$) of Uzbekistan in 2008 to that in 2009?
Give a very brief answer. 0.16. What is the ratio of the Amount (in current US$) of Latin America(developing only) in 2008 to that in 2010?
Your answer should be very brief. 0.44. What is the ratio of the Amount (in current US$) of Sri Lanka in 2008 to that in 2010?
Offer a very short reply. 0.18. What is the ratio of the Amount (in current US$) in Uzbekistan in 2008 to that in 2010?
Make the answer very short. 0.42. What is the ratio of the Amount (in current US$) of Latin America(developing only) in 2008 to that in 2011?
Your answer should be very brief. 0.4. What is the ratio of the Amount (in current US$) in Sri Lanka in 2008 to that in 2011?
Provide a short and direct response. 0.18. What is the ratio of the Amount (in current US$) of Uzbekistan in 2008 to that in 2011?
Your answer should be compact. 0.61. What is the ratio of the Amount (in current US$) in Latin America(developing only) in 2008 to that in 2012?
Your answer should be very brief. 0.37. What is the ratio of the Amount (in current US$) of Sri Lanka in 2008 to that in 2012?
Keep it short and to the point. 0.07. What is the ratio of the Amount (in current US$) in Uzbekistan in 2008 to that in 2012?
Offer a terse response. 0.58. What is the ratio of the Amount (in current US$) in Latin America(developing only) in 2009 to that in 2010?
Your answer should be compact. 0.53. What is the ratio of the Amount (in current US$) of Sri Lanka in 2009 to that in 2010?
Offer a terse response. 0.52. What is the ratio of the Amount (in current US$) in Uzbekistan in 2009 to that in 2010?
Your response must be concise. 2.72. What is the ratio of the Amount (in current US$) in Latin America(developing only) in 2009 to that in 2011?
Give a very brief answer. 0.47. What is the ratio of the Amount (in current US$) of Sri Lanka in 2009 to that in 2011?
Offer a terse response. 0.52. What is the ratio of the Amount (in current US$) of Uzbekistan in 2009 to that in 2011?
Ensure brevity in your answer.  3.9. What is the ratio of the Amount (in current US$) in Latin America(developing only) in 2009 to that in 2012?
Your answer should be compact. 0.44. What is the ratio of the Amount (in current US$) in Sri Lanka in 2009 to that in 2012?
Your answer should be very brief. 0.19. What is the ratio of the Amount (in current US$) in Uzbekistan in 2009 to that in 2012?
Your response must be concise. 3.71. What is the ratio of the Amount (in current US$) of Latin America(developing only) in 2010 to that in 2011?
Offer a very short reply. 0.89. What is the ratio of the Amount (in current US$) of Sri Lanka in 2010 to that in 2011?
Provide a succinct answer. 0.99. What is the ratio of the Amount (in current US$) of Uzbekistan in 2010 to that in 2011?
Provide a short and direct response. 1.43. What is the ratio of the Amount (in current US$) of Latin America(developing only) in 2010 to that in 2012?
Ensure brevity in your answer.  0.83. What is the ratio of the Amount (in current US$) in Sri Lanka in 2010 to that in 2012?
Keep it short and to the point. 0.37. What is the ratio of the Amount (in current US$) in Uzbekistan in 2010 to that in 2012?
Provide a succinct answer. 1.36. What is the ratio of the Amount (in current US$) in Latin America(developing only) in 2011 to that in 2012?
Offer a very short reply. 0.93. What is the ratio of the Amount (in current US$) of Sri Lanka in 2011 to that in 2012?
Your answer should be very brief. 0.37. What is the ratio of the Amount (in current US$) in Uzbekistan in 2011 to that in 2012?
Keep it short and to the point. 0.95. What is the difference between the highest and the second highest Amount (in current US$) in Latin America(developing only)?
Your answer should be compact. 9.33e+09. What is the difference between the highest and the second highest Amount (in current US$) of Bosnia and Herzegovina?
Make the answer very short. 2.56e+08. What is the difference between the highest and the second highest Amount (in current US$) in Sri Lanka?
Offer a terse response. 4.08e+09. What is the difference between the highest and the second highest Amount (in current US$) of Uzbekistan?
Your response must be concise. 1.20e+09. What is the difference between the highest and the lowest Amount (in current US$) in Latin America(developing only)?
Offer a terse response. 1.23e+11. What is the difference between the highest and the lowest Amount (in current US$) in Bosnia and Herzegovina?
Make the answer very short. 9.13e+08. What is the difference between the highest and the lowest Amount (in current US$) in Sri Lanka?
Your response must be concise. 6.04e+09. What is the difference between the highest and the lowest Amount (in current US$) of Uzbekistan?
Provide a succinct answer. 1.90e+09. 